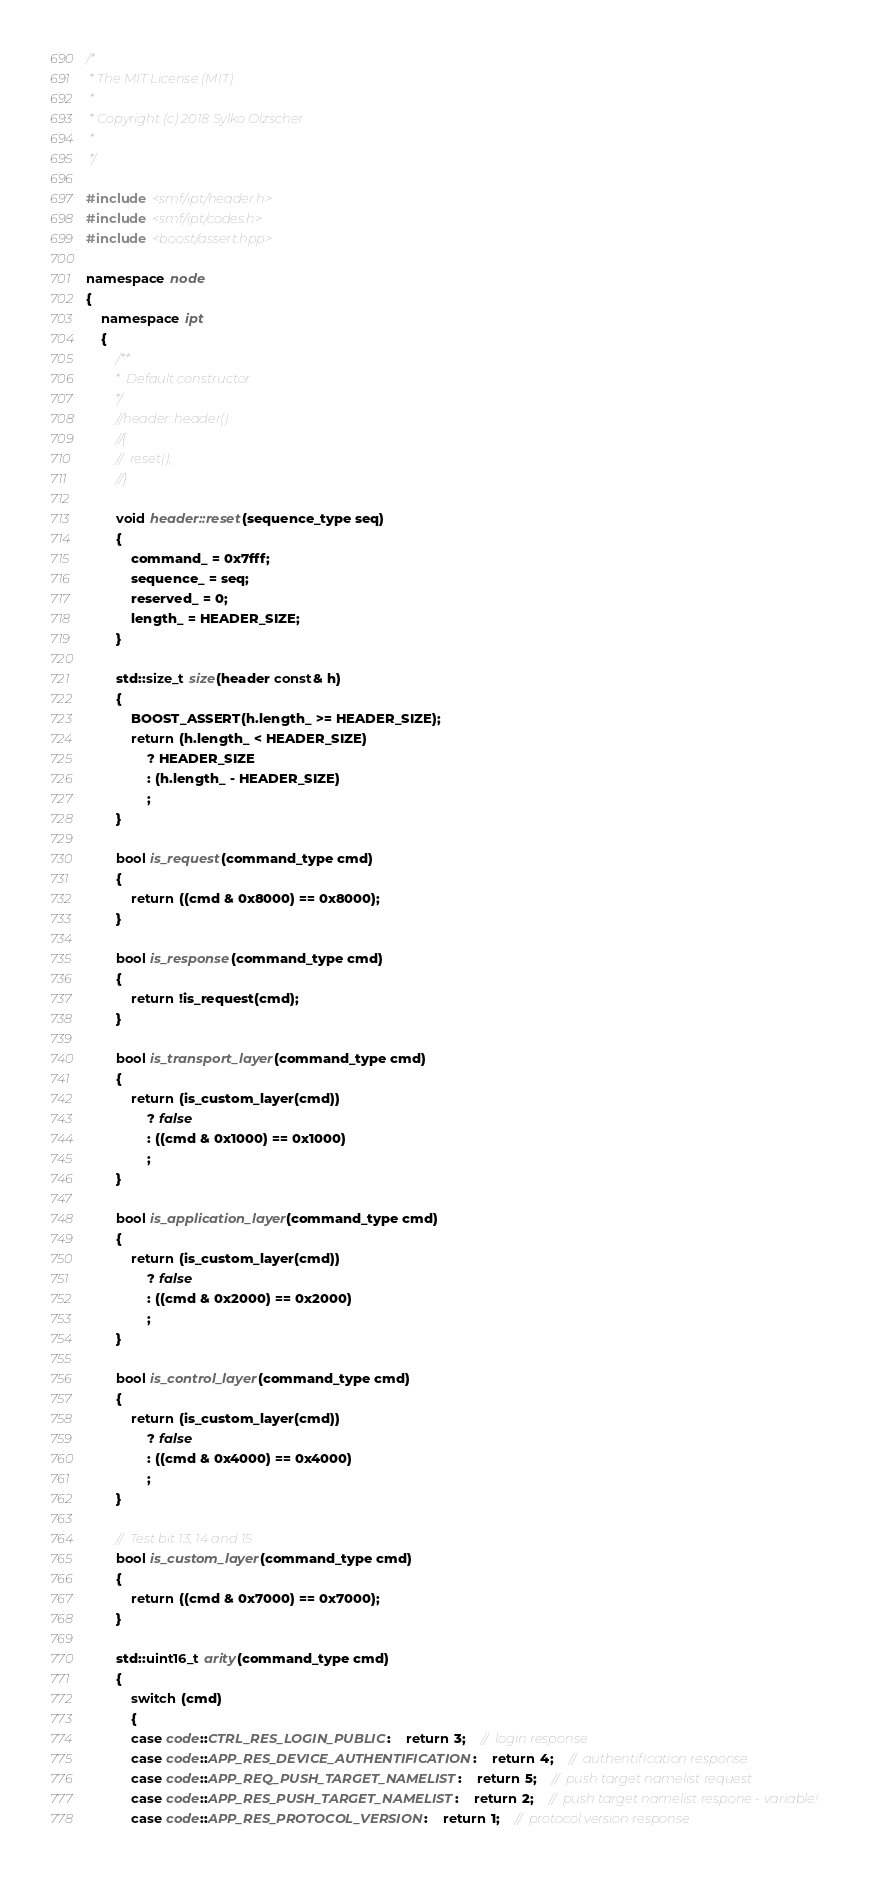<code> <loc_0><loc_0><loc_500><loc_500><_C++_>/*
 * The MIT License (MIT)
 *
 * Copyright (c) 2018 Sylko Olzscher
 *
 */

#include <smf/ipt/header.h>
#include <smf/ipt/codes.h>
#include <boost/assert.hpp>

namespace node
{
	namespace ipt	
	{
		/**
		 *	Default constructor
		 */
		//header::header()
		//{
		//	reset();
		//}

		void header::reset(sequence_type seq)
		{
			command_ = 0x7fff;
			sequence_ = seq;
			reserved_ = 0;
			length_ = HEADER_SIZE;
		}

		std::size_t size(header const& h)
		{
			BOOST_ASSERT(h.length_ >= HEADER_SIZE);
			return (h.length_ < HEADER_SIZE)
				? HEADER_SIZE
				: (h.length_ - HEADER_SIZE)
				;
		}

		bool is_request(command_type cmd)
		{
			return ((cmd & 0x8000) == 0x8000);
		}

		bool is_response(command_type cmd)
		{
			return !is_request(cmd);
		}

		bool is_transport_layer(command_type cmd)
		{
			return (is_custom_layer(cmd))
				? false
				: ((cmd & 0x1000) == 0x1000)
				;
		}

		bool is_application_layer(command_type cmd)
		{
			return (is_custom_layer(cmd))
				? false
				: ((cmd & 0x2000) == 0x2000)
				;
		}

		bool is_control_layer(command_type cmd)
		{
			return (is_custom_layer(cmd))
				? false
				: ((cmd & 0x4000) == 0x4000)
				;
		}

		//	Test bit 13, 14 and 15
		bool is_custom_layer(command_type cmd)
		{
			return ((cmd & 0x7000) == 0x7000);
		}

		std::uint16_t arity(command_type cmd)
		{
			switch (cmd)
			{
			case code::CTRL_RES_LOGIN_PUBLIC:	return 3;	//	login response
			case code::APP_RES_DEVICE_AUTHENTIFICATION:	return 4;	//	authentification response
			case code::APP_REQ_PUSH_TARGET_NAMELIST:	return 5;	//	push target namelist request
			case code::APP_RES_PUSH_TARGET_NAMELIST:	return 2;	//	push target namelist respone - variable!
			case code::APP_RES_PROTOCOL_VERSION:	return 1;	//	protocol version response</code> 